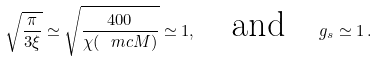<formula> <loc_0><loc_0><loc_500><loc_500>\sqrt { \frac { \pi } { 3 \xi } } \simeq \sqrt { \frac { 4 0 0 } { \chi ( \ m c { M } ) } } \simeq 1 , \quad \text {and} \quad g _ { s } \simeq 1 \, .</formula> 